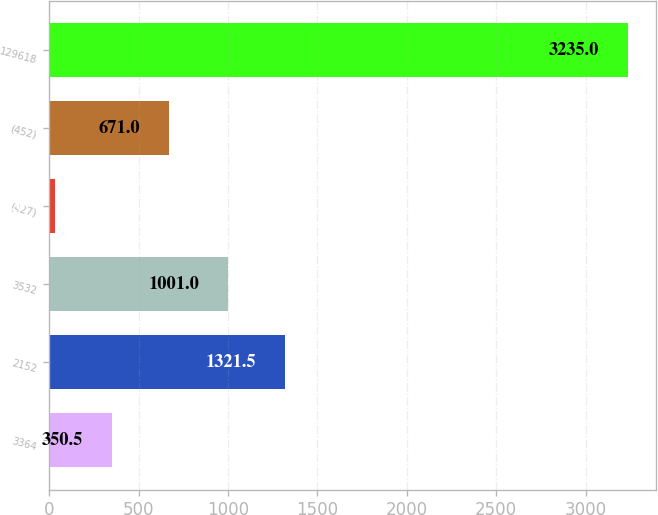<chart> <loc_0><loc_0><loc_500><loc_500><bar_chart><fcel>3364<fcel>2152<fcel>3532<fcel>(427)<fcel>(452)<fcel>129618<nl><fcel>350.5<fcel>1321.5<fcel>1001<fcel>30<fcel>671<fcel>3235<nl></chart> 